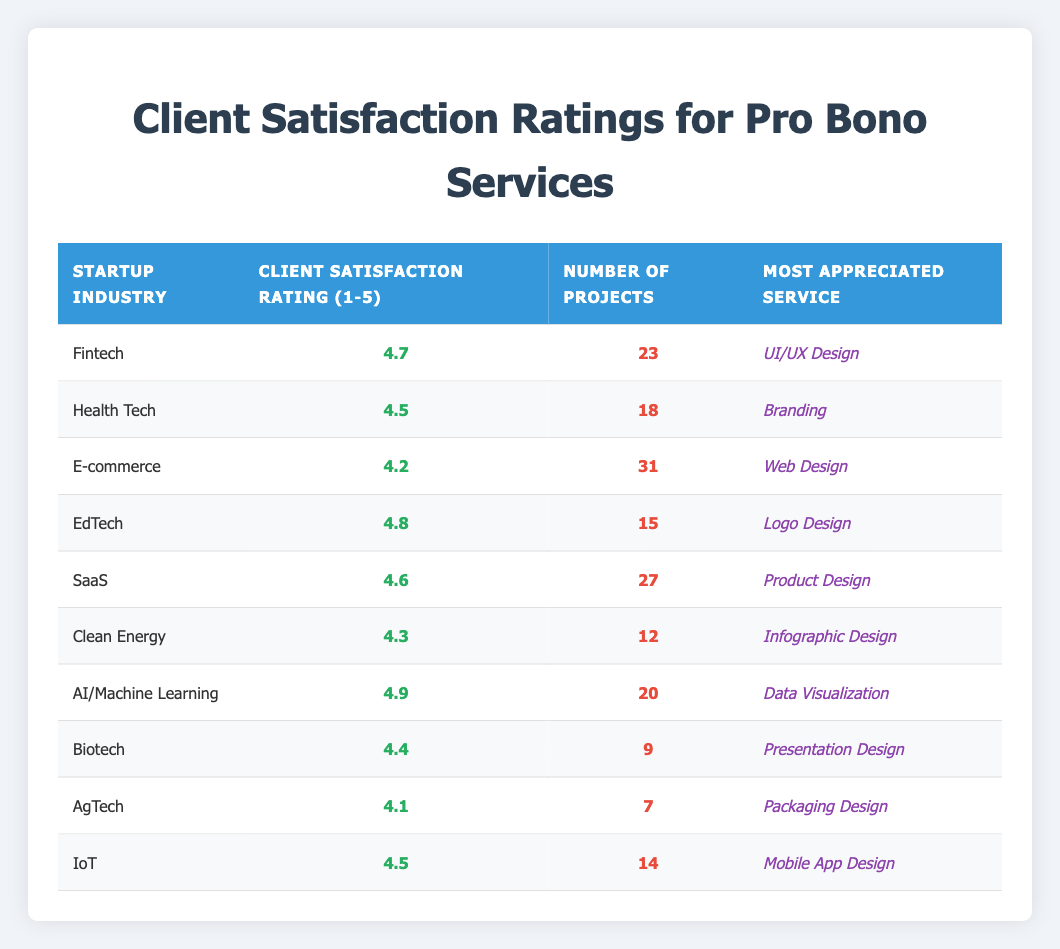What is the highest client satisfaction rating among the startup industries? By reviewing the table, the highest client satisfaction rating can be found by looking at the "Client Satisfaction Rating" column. The rating for AI/Machine Learning is 4.9, which is higher than all other ratings listed.
Answer: 4.9 Which startup industry received the most projects? Inspecting the "Number of Projects" column reveals that E-commerce has received the highest number of projects, totaling 31.
Answer: E-commerce What is the average client satisfaction rating for all listed startup industries? To calculate the average, add up all the satisfaction ratings: 4.7 + 4.5 + 4.2 + 4.8 + 4.6 + 4.3 + 4.9 + 4.4 + 4.1 + 4.5 = 46.0. There are 10 industries, so the average is 46.0 / 10 = 4.6.
Answer: 4.6 Did any startup industry have a client satisfaction rating below 4.2? Looking through the ratings listed, AgTech has a rating of 4.1, which is below 4.2. Thus, the statement is true.
Answer: Yes Which service was most appreciated in Health Tech? Referring to the "Most Appreciated Service" column for Health Tech, the service appreciated the most was Branding.
Answer: Branding What is the difference in client satisfaction ratings between the E-commerce and Clean Energy industries? The client satisfaction rating for E-commerce is 4.2, and for Clean Energy, it is 4.3. The difference is calculated as 4.3 - 4.2 = 0.1.
Answer: 0.1 Which industry has fewer projects, Biotech or AgTech? Biotech has 9 projects while AgTech has 7 projects. Since 7 is less than 9, AgTech has fewer projects.
Answer: AgTech Which startup industry supplied the most appreciated service of UI/UX Design? The table shows that the Fintech industry lists UI/UX Design as its most appreciated service.
Answer: Fintech What are the client satisfaction ratings for AI/Machine Learning and Clean Energy combined? The rating for AI/Machine Learning is 4.9, and for Clean Energy, it is 4.3. Adding these gives 4.9 + 4.3 = 9.2.
Answer: 9.2 